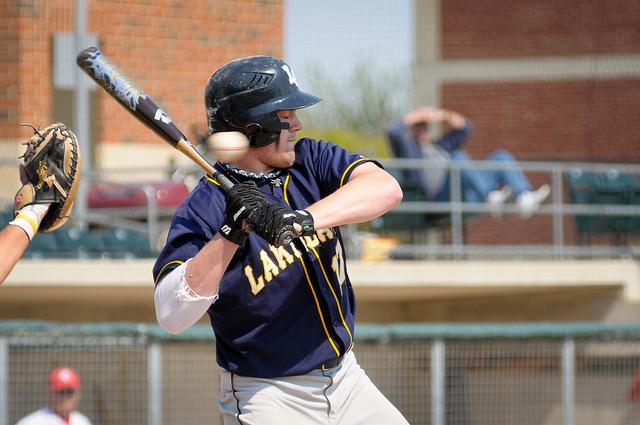Where is the spectator placing his feet?
Quick response, please. On rail. Is the batter a lefty?
Keep it brief. No. Is the batter going to hit the ball?
Write a very short answer. Yes. 